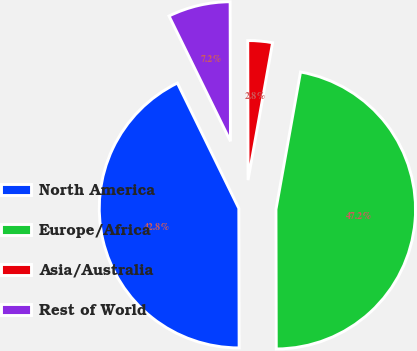Convert chart to OTSL. <chart><loc_0><loc_0><loc_500><loc_500><pie_chart><fcel>North America<fcel>Europe/Africa<fcel>Asia/Australia<fcel>Rest of World<nl><fcel>42.78%<fcel>47.15%<fcel>2.85%<fcel>7.22%<nl></chart> 